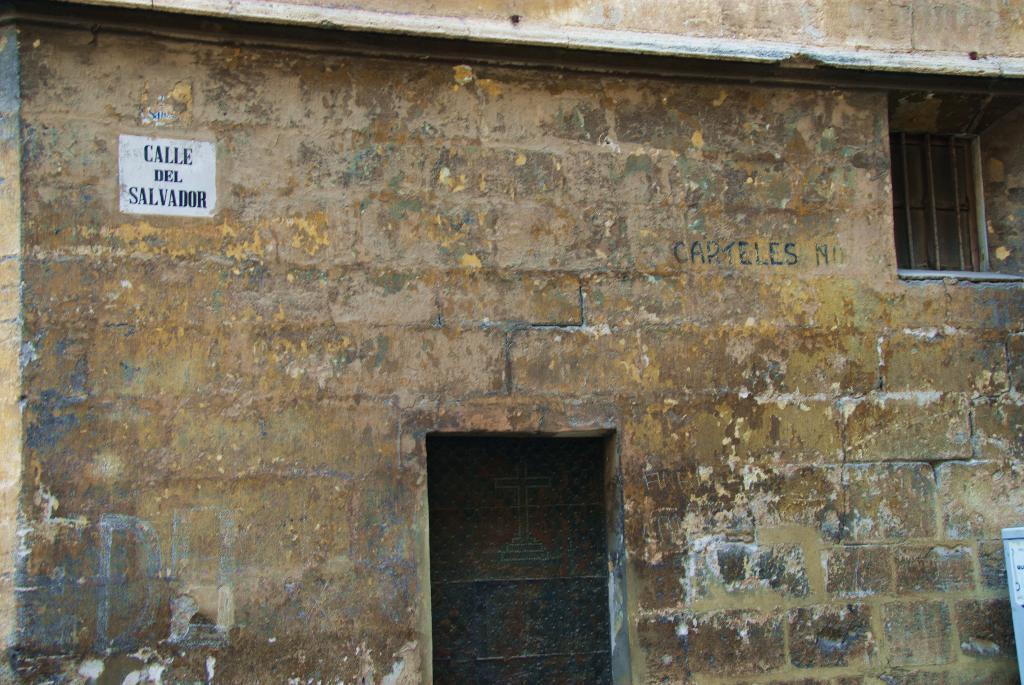How would you summarize this image in a sentence or two? In this picture we can see an object, window, door and a sticker on the wall. 